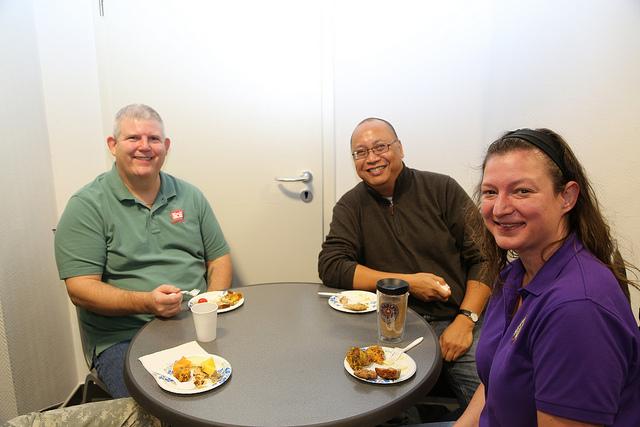What food is shown?
Concise answer only. Chicken. Who has a utensil in their right hand?
Concise answer only. Man in green shirt. Does everyone have cooked chicken on their plates?
Concise answer only. No. 